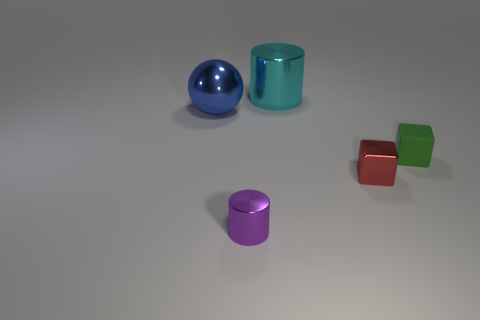Add 3 yellow objects. How many objects exist? 8 Subtract all cylinders. How many objects are left? 3 Add 3 small red metal cubes. How many small red metal cubes are left? 4 Add 2 large yellow metal cylinders. How many large yellow metal cylinders exist? 2 Subtract 0 blue cylinders. How many objects are left? 5 Subtract all shiny blocks. Subtract all small green rubber cubes. How many objects are left? 3 